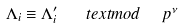<formula> <loc_0><loc_0><loc_500><loc_500>\Lambda _ { i } \equiv \Lambda ^ { \prime } _ { i } \quad t e x t { m o d } \ \ p ^ { \nu }</formula> 